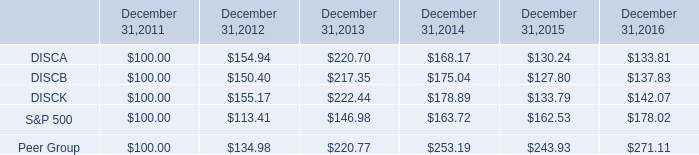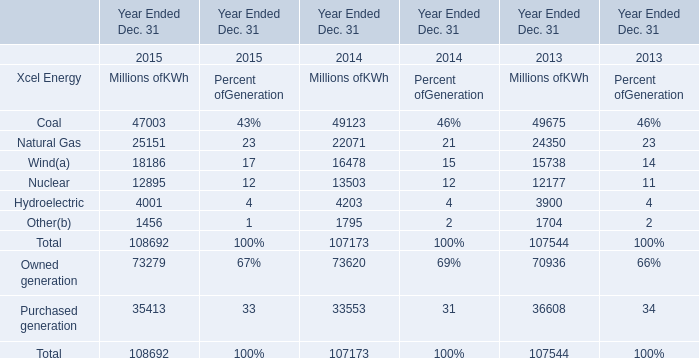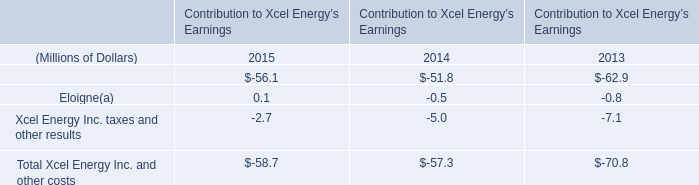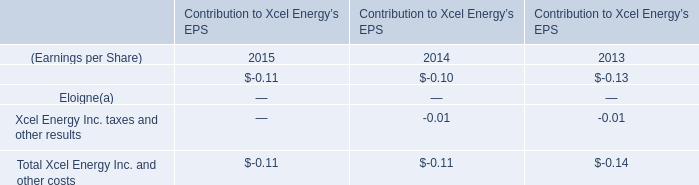In the year with the most Eloigne(a) in Table 2, what is the growth rate of Hydroelectric of Millions ofKWh in Table 1? 
Computations: ((4001 - 4203) / 4203)
Answer: -0.04806. 